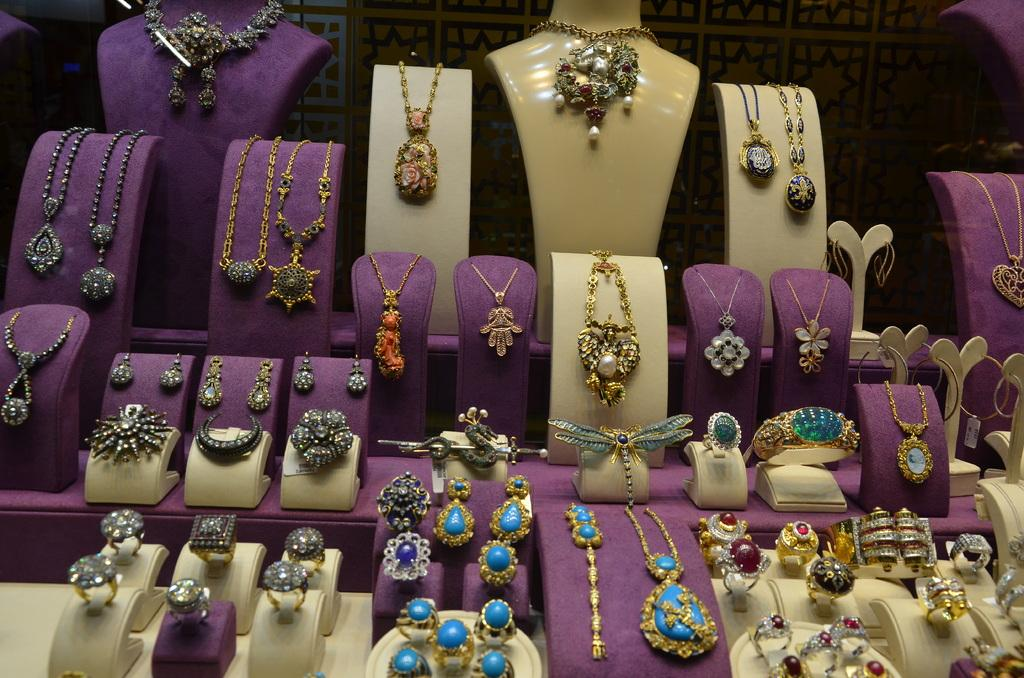What type of objects are featured in the image? There are jewelry stands in the image. What colors are the jewelry stands? The jewelry stands are in violet and cream color. What types of jewelry can be seen on the stands? There are different types of jewelry on the stands, including rings and pendants. What type of fuel is being used to power the jewelry stands in the image? There is no indication in the image that the jewelry stands require any fuel to function. --- 